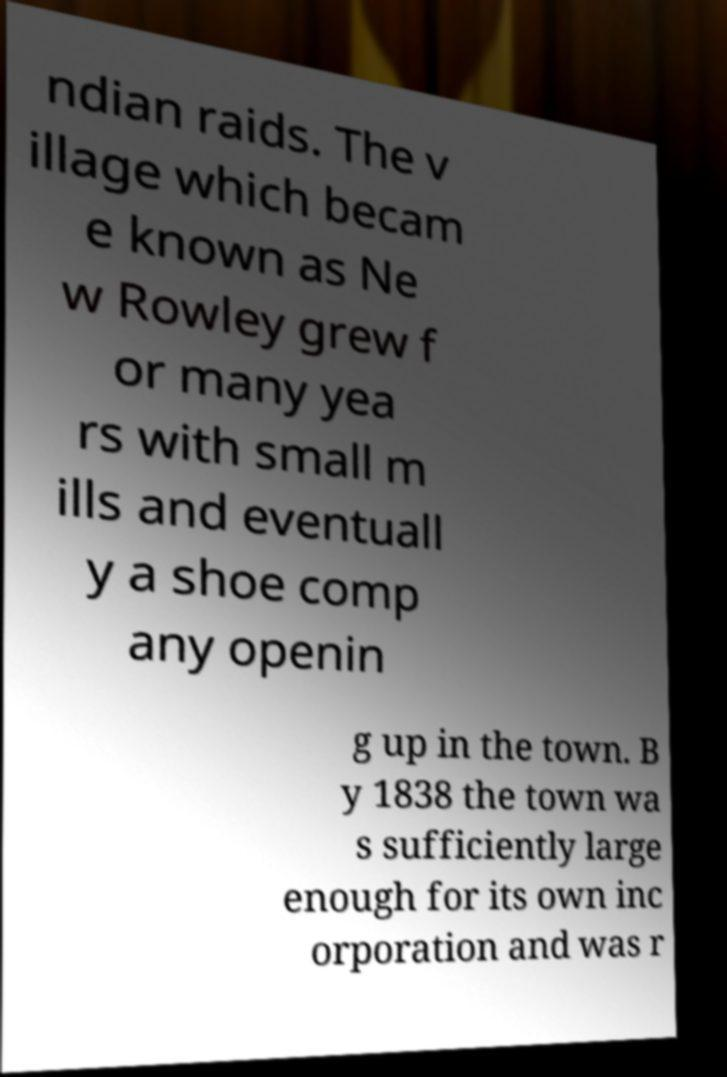Please identify and transcribe the text found in this image. ndian raids. The v illage which becam e known as Ne w Rowley grew f or many yea rs with small m ills and eventuall y a shoe comp any openin g up in the town. B y 1838 the town wa s sufficiently large enough for its own inc orporation and was r 